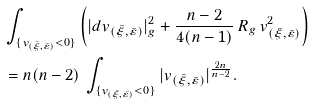<formula> <loc_0><loc_0><loc_500><loc_500>& \int _ { \{ v _ { ( \bar { \xi } , \bar { \varepsilon } ) } < 0 \} } \left ( | d v _ { ( \bar { \xi } , \bar { \varepsilon } ) } | _ { g } ^ { 2 } + \frac { n - 2 } { 4 ( n - 1 ) } \, R _ { g } \, v _ { ( \bar { \xi } , \bar { \varepsilon } ) } ^ { 2 } \right ) \\ & = n ( n - 2 ) \, \int _ { \{ v _ { ( \bar { \xi } , \bar { \varepsilon } ) } < 0 \} } | v _ { ( \bar { \xi } , \bar { \varepsilon } ) } | ^ { \frac { 2 n } { n - 2 } } .</formula> 